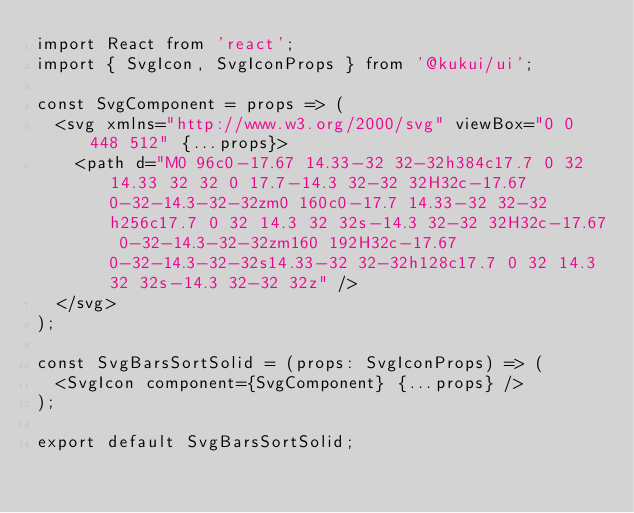<code> <loc_0><loc_0><loc_500><loc_500><_TypeScript_>import React from 'react';
import { SvgIcon, SvgIconProps } from '@kukui/ui';

const SvgComponent = props => (
  <svg xmlns="http://www.w3.org/2000/svg" viewBox="0 0 448 512" {...props}>
    <path d="M0 96c0-17.67 14.33-32 32-32h384c17.7 0 32 14.33 32 32 0 17.7-14.3 32-32 32H32c-17.67 0-32-14.3-32-32zm0 160c0-17.7 14.33-32 32-32h256c17.7 0 32 14.3 32 32s-14.3 32-32 32H32c-17.67 0-32-14.3-32-32zm160 192H32c-17.67 0-32-14.3-32-32s14.33-32 32-32h128c17.7 0 32 14.3 32 32s-14.3 32-32 32z" />
  </svg>
);

const SvgBarsSortSolid = (props: SvgIconProps) => (
  <SvgIcon component={SvgComponent} {...props} />
);

export default SvgBarsSortSolid;
</code> 